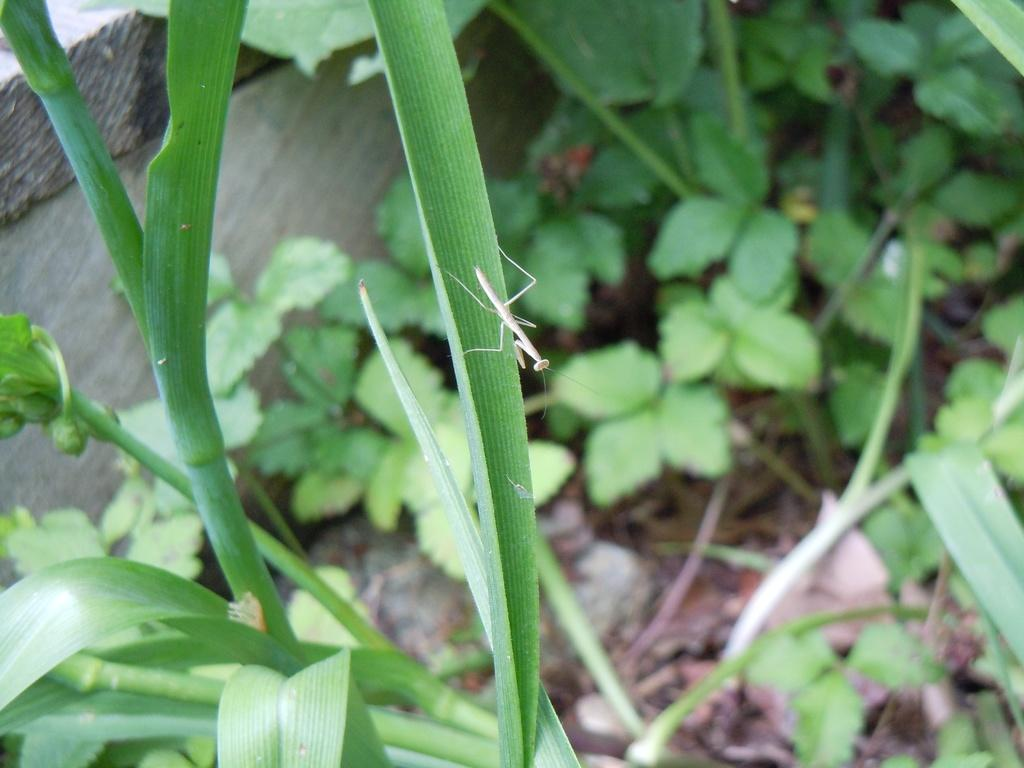What type of living organisms can be seen in the image? Plants can be seen in the image. Is there any other type of living organism present in the image? Yes, there is an insect on one of the plants. What type of cloth is being used to cover the snow in the image? There is no snow or cloth present in the image; it features plants and an insect. 